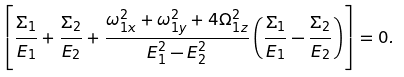Convert formula to latex. <formula><loc_0><loc_0><loc_500><loc_500>\left [ \frac { \Sigma _ { 1 } } { E _ { 1 } } + \frac { \Sigma _ { 2 } } { E _ { 2 } } + \frac { \omega _ { 1 x } ^ { 2 } + \omega _ { 1 y } ^ { 2 } + 4 \Omega _ { 1 z } ^ { 2 } } { E _ { 1 } ^ { 2 } - E _ { 2 } ^ { 2 } } \left ( \frac { \Sigma _ { 1 } } { E _ { 1 } } - \frac { \Sigma _ { 2 } } { E _ { 2 } } \right ) \right ] = 0 .</formula> 